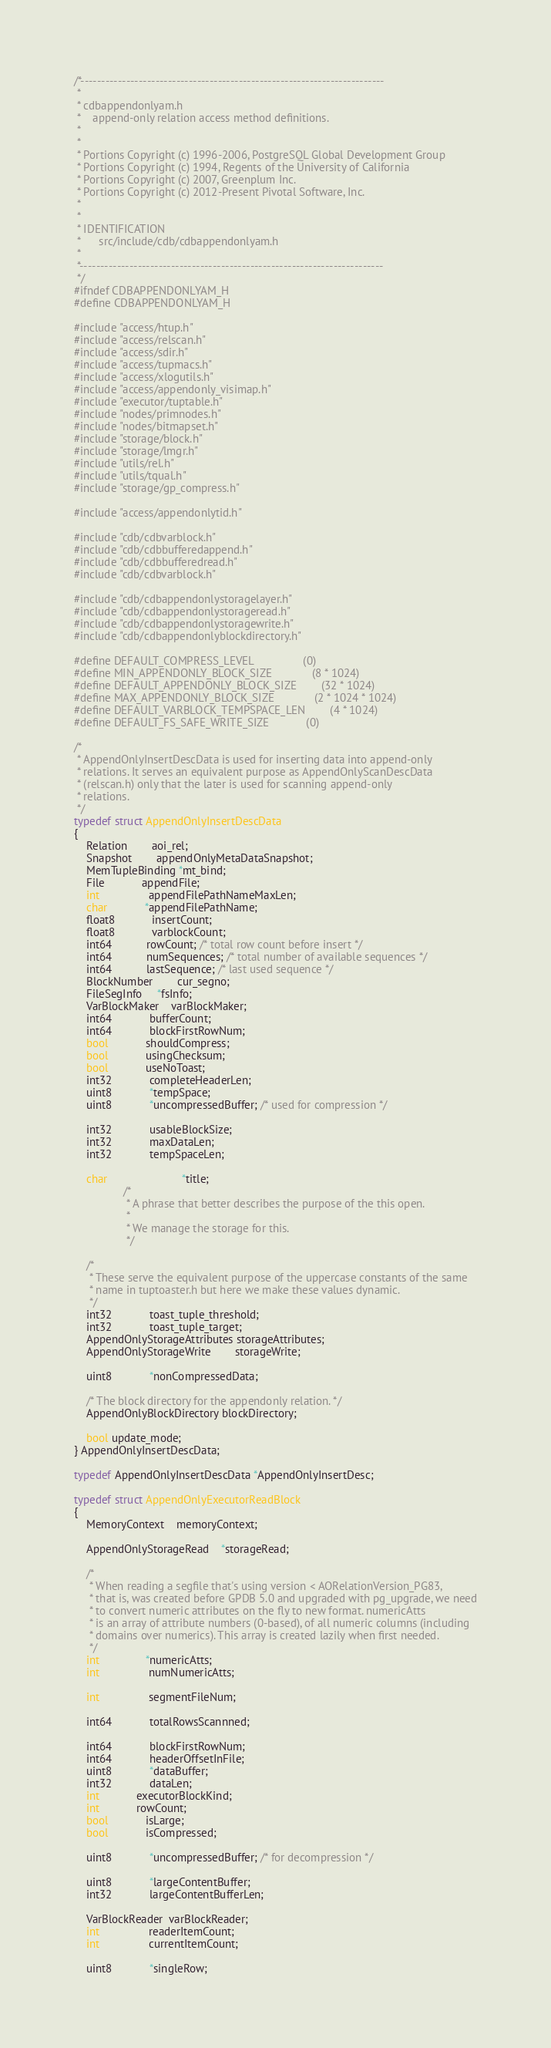Convert code to text. <code><loc_0><loc_0><loc_500><loc_500><_C_>/*-------------------------------------------------------------------------
 *
 * cdbappendonlyam.h
 *	  append-only relation access method definitions.
 *
 *
 * Portions Copyright (c) 1996-2006, PostgreSQL Global Development Group
 * Portions Copyright (c) 1994, Regents of the University of California
 * Portions Copyright (c) 2007, Greenplum Inc.
 * Portions Copyright (c) 2012-Present Pivotal Software, Inc.
 *
 *
 * IDENTIFICATION
 *	    src/include/cdb/cdbappendonlyam.h
 *
 *-------------------------------------------------------------------------
 */
#ifndef CDBAPPENDONLYAM_H
#define CDBAPPENDONLYAM_H

#include "access/htup.h"
#include "access/relscan.h"
#include "access/sdir.h"
#include "access/tupmacs.h"
#include "access/xlogutils.h"
#include "access/appendonly_visimap.h"
#include "executor/tuptable.h"
#include "nodes/primnodes.h"
#include "nodes/bitmapset.h"
#include "storage/block.h"
#include "storage/lmgr.h"
#include "utils/rel.h"
#include "utils/tqual.h"
#include "storage/gp_compress.h"

#include "access/appendonlytid.h"

#include "cdb/cdbvarblock.h"
#include "cdb/cdbbufferedappend.h"
#include "cdb/cdbbufferedread.h"
#include "cdb/cdbvarblock.h"

#include "cdb/cdbappendonlystoragelayer.h"
#include "cdb/cdbappendonlystorageread.h"
#include "cdb/cdbappendonlystoragewrite.h"
#include "cdb/cdbappendonlyblockdirectory.h"

#define DEFAULT_COMPRESS_LEVEL				 (0)
#define MIN_APPENDONLY_BLOCK_SIZE			 (8 * 1024)
#define DEFAULT_APPENDONLY_BLOCK_SIZE		(32 * 1024)
#define MAX_APPENDONLY_BLOCK_SIZE			 (2 * 1024 * 1024)
#define DEFAULT_VARBLOCK_TEMPSPACE_LEN   	 (4 * 1024)
#define DEFAULT_FS_SAFE_WRITE_SIZE			 (0)

/*
 * AppendOnlyInsertDescData is used for inserting data into append-only
 * relations. It serves an equivalent purpose as AppendOnlyScanDescData
 * (relscan.h) only that the later is used for scanning append-only 
 * relations. 
 */
typedef struct AppendOnlyInsertDescData
{
	Relation		aoi_rel;
	Snapshot		appendOnlyMetaDataSnapshot;
	MemTupleBinding *mt_bind;
	File			appendFile;
	int				appendFilePathNameMaxLen;
	char			*appendFilePathName;
	float8			insertCount;
	float8			varblockCount;
	int64           rowCount; /* total row count before insert */
	int64           numSequences; /* total number of available sequences */
	int64           lastSequence; /* last used sequence */
	BlockNumber		cur_segno;
	FileSegInfo     *fsInfo;
	VarBlockMaker	varBlockMaker;
	int64			bufferCount;
	int64			blockFirstRowNum;
	bool			shouldCompress;
	bool			usingChecksum;
	bool			useNoToast;
	int32			completeHeaderLen;
	uint8			*tempSpace;
	uint8			*uncompressedBuffer; /* used for compression */

	int32			usableBlockSize;
	int32			maxDataLen;
	int32			tempSpaceLen;

	char						*title;
				/*
				 * A phrase that better describes the purpose of the this open.
				 *
				 * We manage the storage for this.
				 */

	/*
	 * These serve the equivalent purpose of the uppercase constants of the same
	 * name in tuptoaster.h but here we make these values dynamic.
	 */	
	int32			toast_tuple_threshold;
	int32			toast_tuple_target;
	AppendOnlyStorageAttributes storageAttributes;
	AppendOnlyStorageWrite		storageWrite;

	uint8			*nonCompressedData;

	/* The block directory for the appendonly relation. */
	AppendOnlyBlockDirectory blockDirectory;

	bool update_mode;
} AppendOnlyInsertDescData;

typedef AppendOnlyInsertDescData *AppendOnlyInsertDesc;

typedef struct AppendOnlyExecutorReadBlock
{
	MemoryContext	memoryContext;

	AppendOnlyStorageRead	*storageRead;

	/*
	 * When reading a segfile that's using version < AORelationVersion_PG83,
	 * that is, was created before GPDB 5.0 and upgraded with pg_upgrade, we need
	 * to convert numeric attributes on the fly to new format. numericAtts
	 * is an array of attribute numbers (0-based), of all numeric columns (including
	 * domains over numerics). This array is created lazily when first needed.
	 */
	int			   *numericAtts;
	int				numNumericAtts;

	int				segmentFileNum;

	int64			totalRowsScannned;

	int64			blockFirstRowNum;
	int64			headerOffsetInFile;
	uint8			*dataBuffer;
	int32			dataLen;
	int 			executorBlockKind;
	int 			rowCount;
	bool			isLarge;
	bool			isCompressed;

	uint8			*uncompressedBuffer; /* for decompression */

	uint8			*largeContentBuffer;
	int32			largeContentBufferLen;

	VarBlockReader  varBlockReader;
	int				readerItemCount;
	int				currentItemCount;
	
	uint8			*singleRow;</code> 